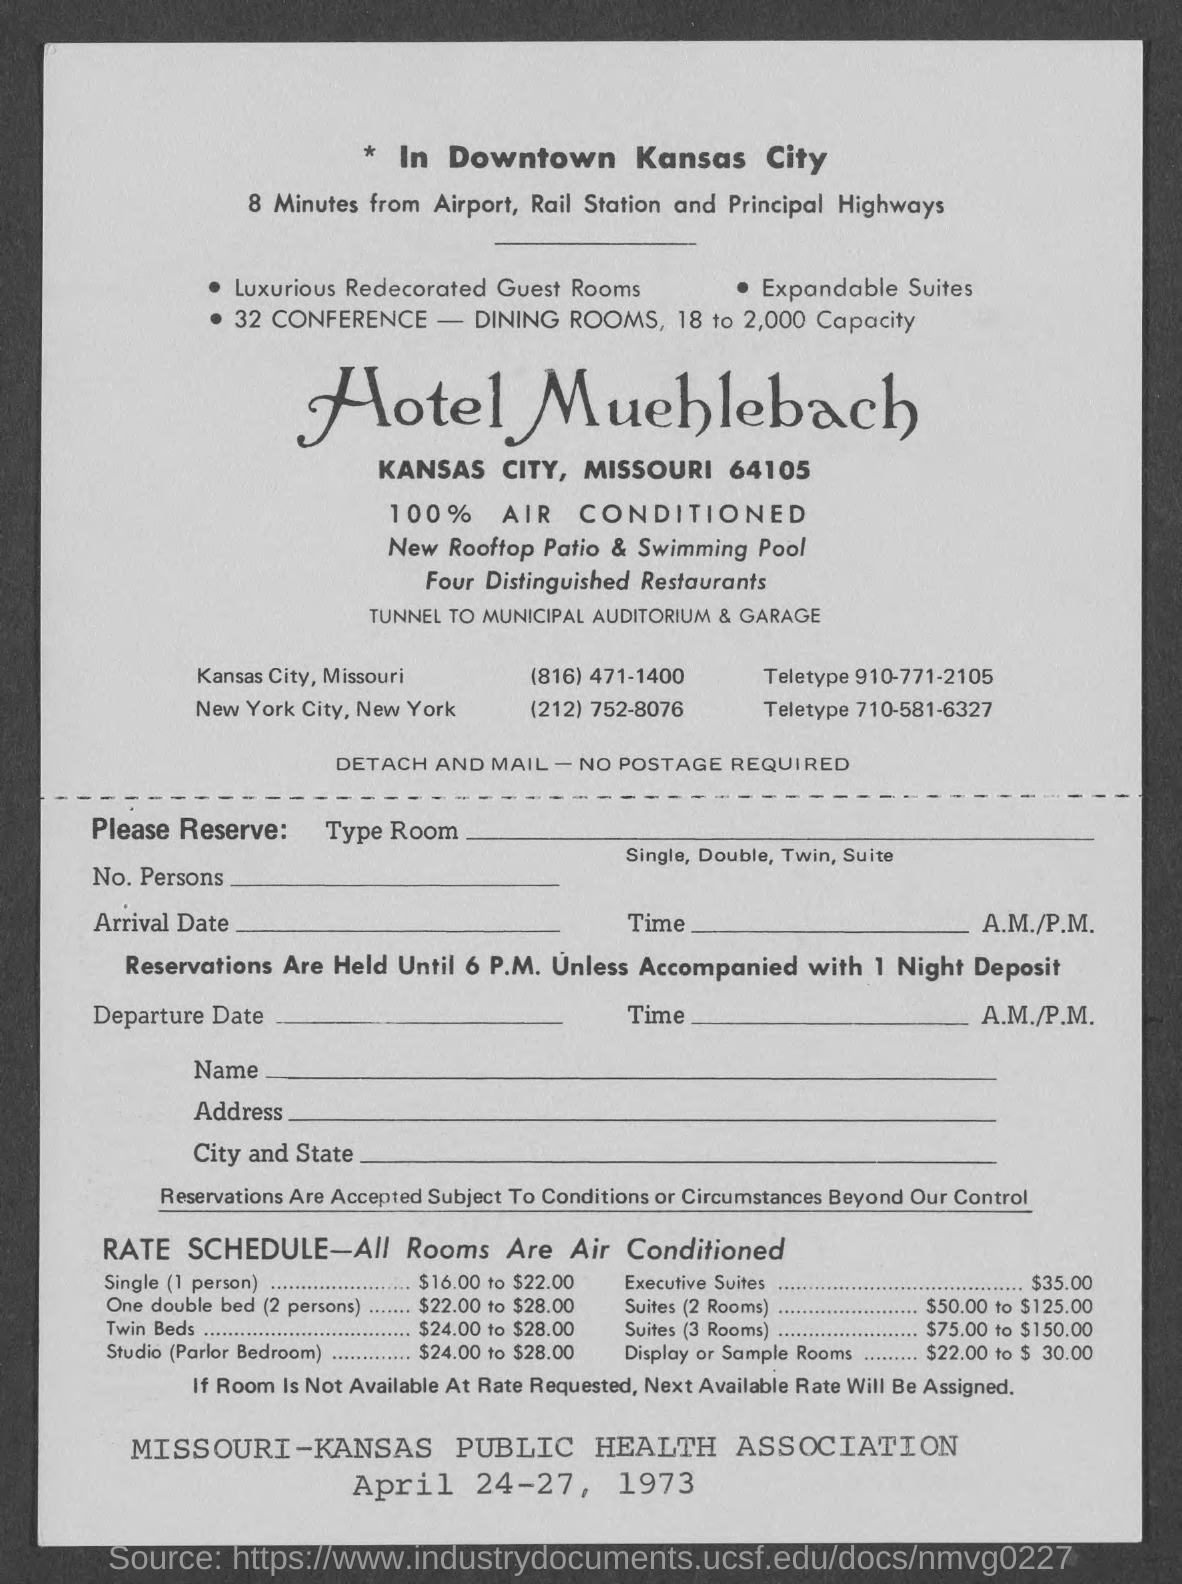Outline some significant characteristics in this image. The document is dated from April 24-27, 1973. The teletype number for the Kansas City hotel is 910-771-2105. The hotel is located in the heart of downtown Kansas City. The hotel is located 8 minutes away from the airport, rail station, and major highways. There are four distinguished restaurants in this area. 